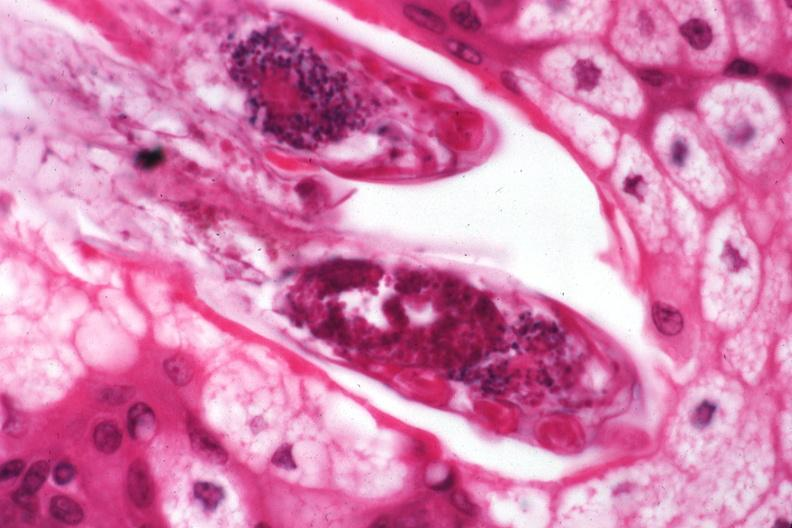does testicle show demodex folliculorum?
Answer the question using a single word or phrase. No 